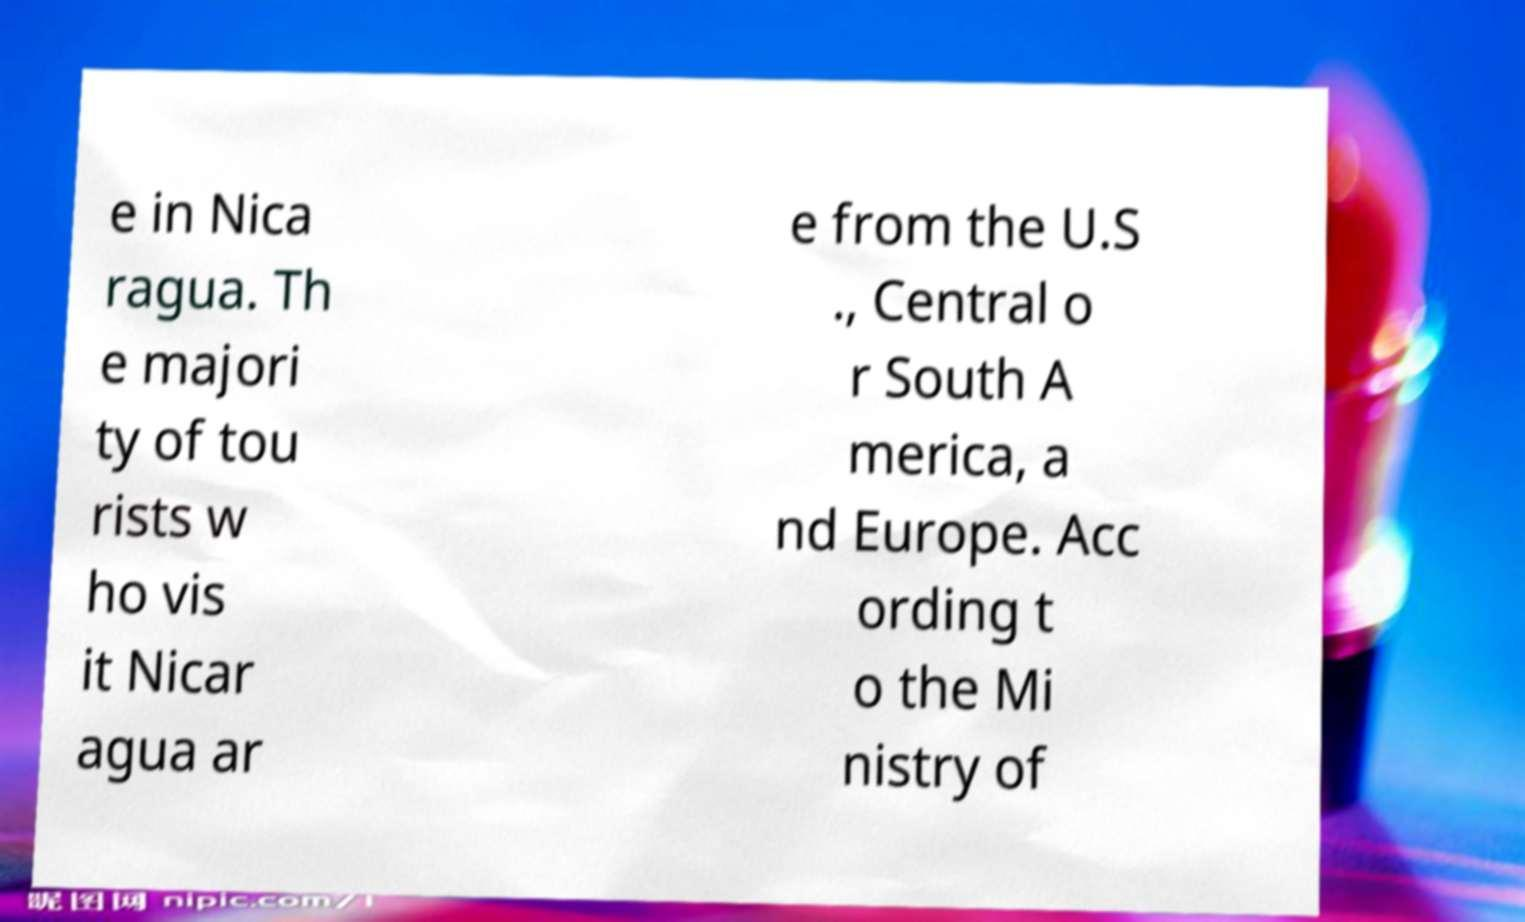Please read and relay the text visible in this image. What does it say? e in Nica ragua. Th e majori ty of tou rists w ho vis it Nicar agua ar e from the U.S ., Central o r South A merica, a nd Europe. Acc ording t o the Mi nistry of 